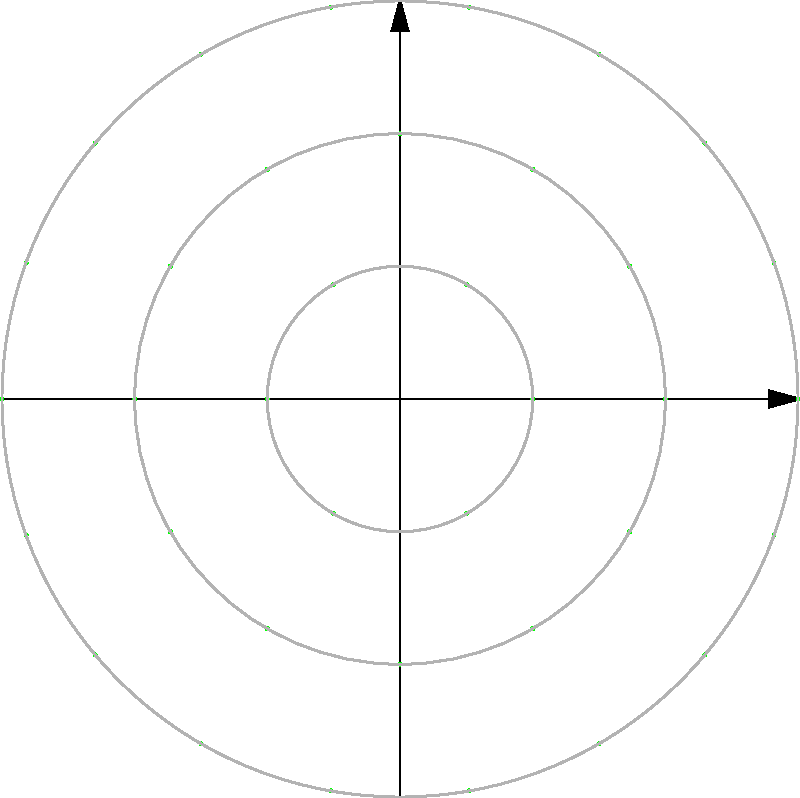In a circular garden design, trees are planted in three concentric rings as shown in the diagram. The innermost ring has a radius of 2 meters and contains 6 trees, the middle ring has a radius of 4 meters and contains 12 trees, and the outermost ring has a radius of 6 meters and contains 18 trees. What is the optimal spacing between trees in the outermost ring to ensure uniform growth and aesthetic appeal? To find the optimal spacing between trees in the outermost ring, we need to calculate the arc length between adjacent trees. Here's how we can do this:

1. The circumference of a circle is given by the formula $C = 2\pi r$, where $r$ is the radius.

2. For the outermost ring:
   Radius $r = 6$ meters
   Circumference $C = 2\pi(6) = 12\pi$ meters

3. There are 18 trees in the outermost ring, so we need to divide the circumference by 18 to get the spacing:

   Spacing $= \frac{12\pi}{18} = \frac{2\pi}{3}$ meters

4. To simplify:
   $\frac{2\pi}{3} \approx 2.0944$ meters

Therefore, the optimal spacing between trees in the outermost ring is approximately 2.0944 meters or $\frac{2\pi}{3}$ meters.

This spacing ensures that the trees are evenly distributed around the ring, which promotes uniform growth and creates an aesthetically pleasing arrangement for the topiary art.
Answer: $\frac{2\pi}{3}$ meters 